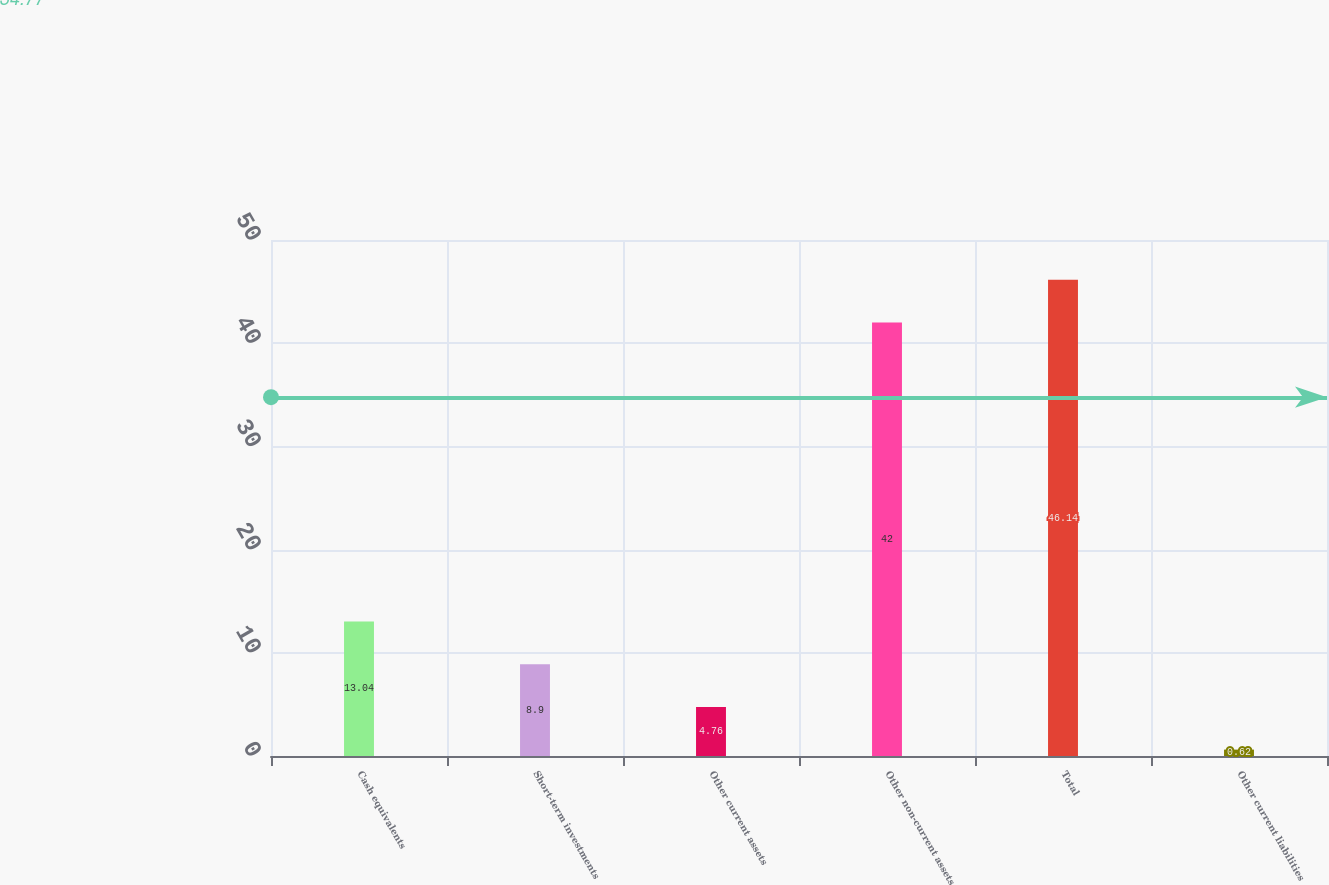<chart> <loc_0><loc_0><loc_500><loc_500><bar_chart><fcel>Cash equivalents<fcel>Short-term investments<fcel>Other current assets<fcel>Other non-current assets<fcel>Total<fcel>Other current liabilities<nl><fcel>13.04<fcel>8.9<fcel>4.76<fcel>42<fcel>46.14<fcel>0.62<nl></chart> 